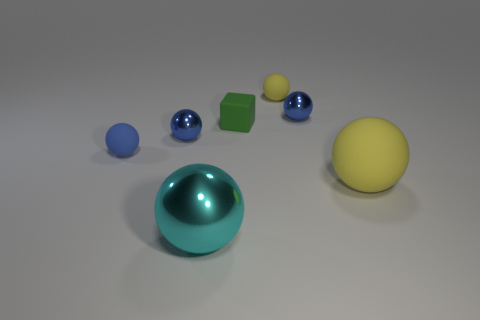What material is the other yellow thing that is the same shape as the large rubber thing?
Provide a short and direct response. Rubber. How many matte objects are the same color as the cube?
Give a very brief answer. 0. What is the size of the cube that is made of the same material as the small yellow thing?
Ensure brevity in your answer.  Small. How many gray things are rubber cylinders or spheres?
Offer a terse response. 0. There is a yellow object that is left of the large matte thing; how many metal balls are right of it?
Give a very brief answer. 1. Are there more blocks that are left of the tiny yellow sphere than metal balls that are in front of the big matte object?
Provide a short and direct response. No. What is the material of the large cyan object?
Provide a succinct answer. Metal. Are there any green shiny balls of the same size as the cyan shiny object?
Offer a terse response. No. What material is the yellow ball that is the same size as the green object?
Your response must be concise. Rubber. What number of cyan metallic spheres are there?
Your answer should be very brief. 1. 